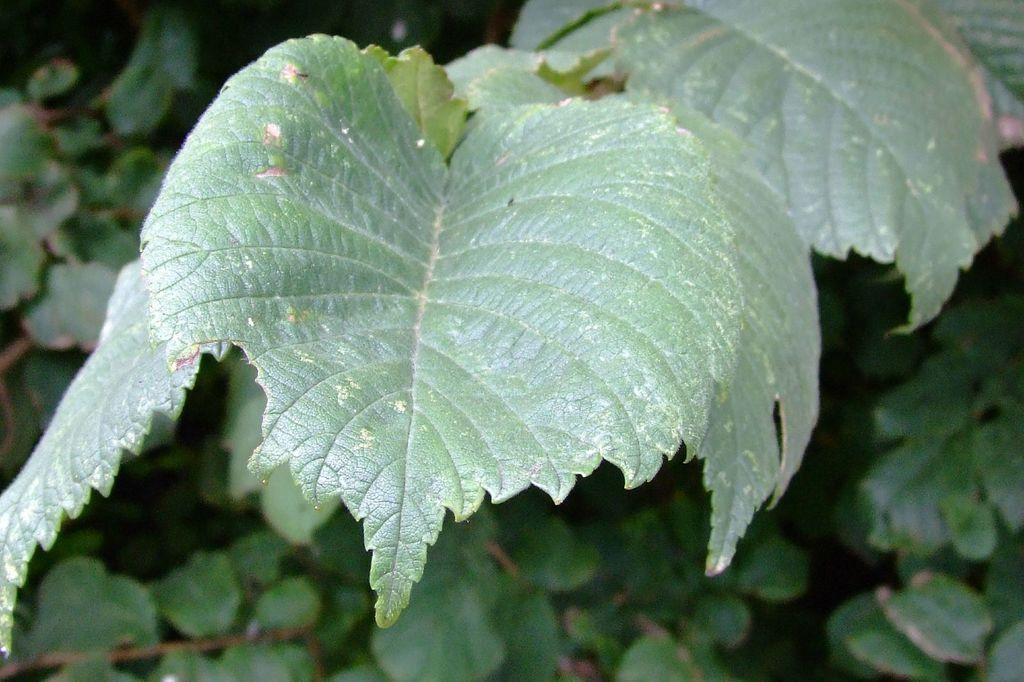Please provide a concise description of this image. In this image I can see few leaves which are green in color and in the background I can see few trees which are green and brown in color. 